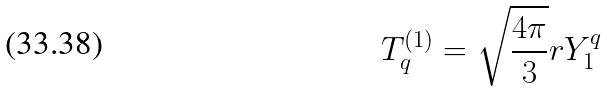Convert formula to latex. <formula><loc_0><loc_0><loc_500><loc_500>T _ { q } ^ { ( 1 ) } = \sqrt { \frac { 4 \pi } { 3 } } r Y _ { 1 } ^ { q }</formula> 